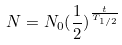<formula> <loc_0><loc_0><loc_500><loc_500>N = N _ { 0 } ( \frac { 1 } { 2 } ) ^ { \frac { t } { T _ { 1 / 2 } } }</formula> 